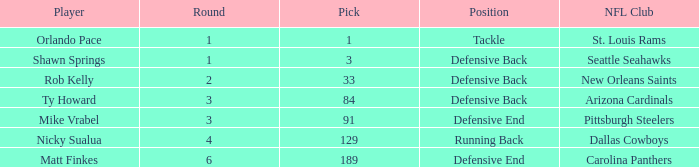What round has a pick less than 189, with arizona cardinals as the NFL club? 3.0. 